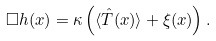<formula> <loc_0><loc_0><loc_500><loc_500>\Box h ( x ) = \kappa \left ( \langle \hat { T } ( x ) \rangle + \xi ( x ) \right ) .</formula> 